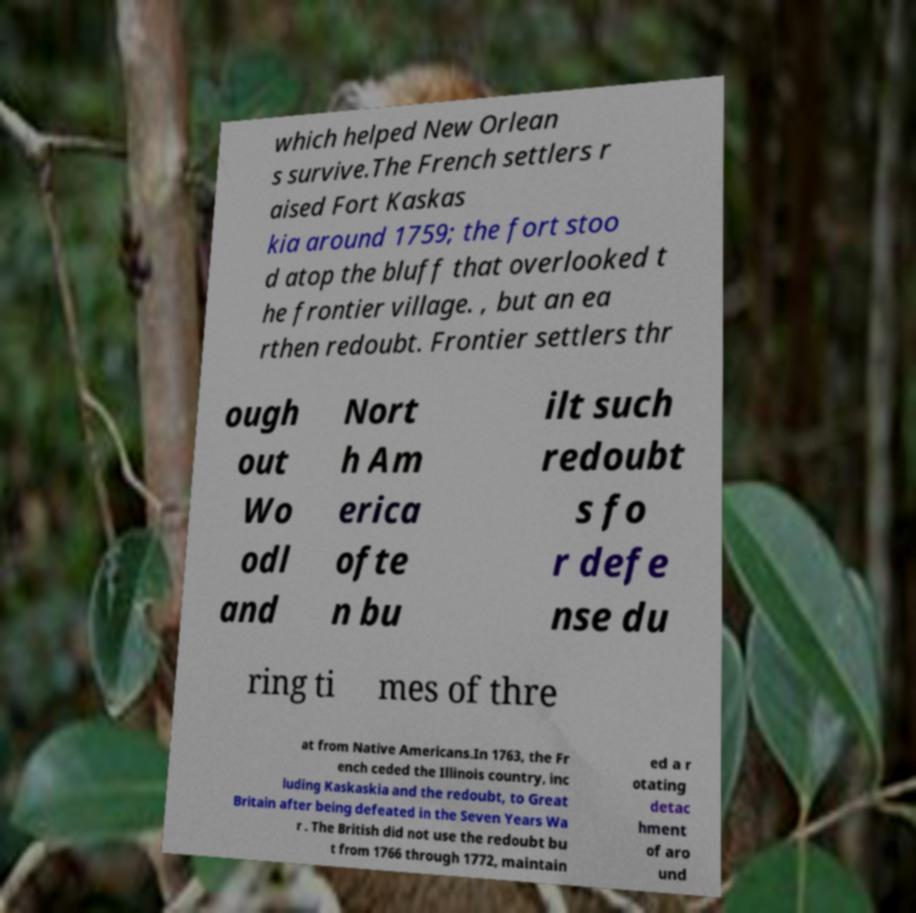Please read and relay the text visible in this image. What does it say? which helped New Orlean s survive.The French settlers r aised Fort Kaskas kia around 1759; the fort stoo d atop the bluff that overlooked t he frontier village. , but an ea rthen redoubt. Frontier settlers thr ough out Wo odl and Nort h Am erica ofte n bu ilt such redoubt s fo r defe nse du ring ti mes of thre at from Native Americans.In 1763, the Fr ench ceded the Illinois country, inc luding Kaskaskia and the redoubt, to Great Britain after being defeated in the Seven Years Wa r . The British did not use the redoubt bu t from 1766 through 1772, maintain ed a r otating detac hment of aro und 